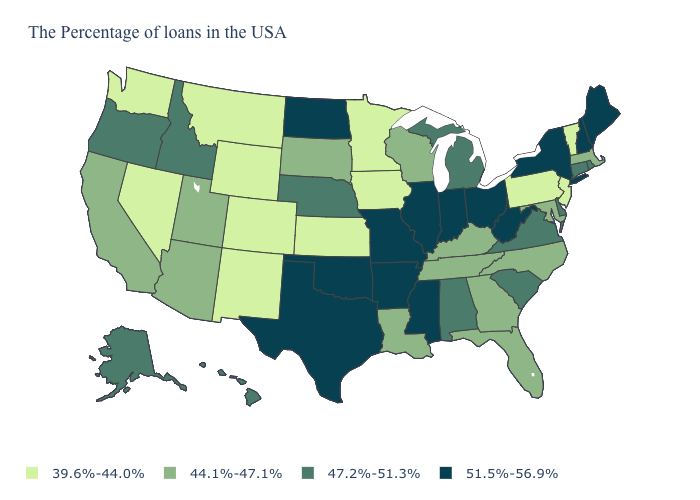Does Florida have the highest value in the South?
Concise answer only. No. Which states have the lowest value in the USA?
Be succinct. Vermont, New Jersey, Pennsylvania, Minnesota, Iowa, Kansas, Wyoming, Colorado, New Mexico, Montana, Nevada, Washington. Name the states that have a value in the range 44.1%-47.1%?
Short answer required. Massachusetts, Maryland, North Carolina, Florida, Georgia, Kentucky, Tennessee, Wisconsin, Louisiana, South Dakota, Utah, Arizona, California. How many symbols are there in the legend?
Quick response, please. 4. Does the first symbol in the legend represent the smallest category?
Answer briefly. Yes. Name the states that have a value in the range 39.6%-44.0%?
Keep it brief. Vermont, New Jersey, Pennsylvania, Minnesota, Iowa, Kansas, Wyoming, Colorado, New Mexico, Montana, Nevada, Washington. Does the first symbol in the legend represent the smallest category?
Be succinct. Yes. Among the states that border Nevada , does Oregon have the lowest value?
Quick response, please. No. Does Maryland have the same value as Illinois?
Write a very short answer. No. Name the states that have a value in the range 44.1%-47.1%?
Keep it brief. Massachusetts, Maryland, North Carolina, Florida, Georgia, Kentucky, Tennessee, Wisconsin, Louisiana, South Dakota, Utah, Arizona, California. Name the states that have a value in the range 44.1%-47.1%?
Keep it brief. Massachusetts, Maryland, North Carolina, Florida, Georgia, Kentucky, Tennessee, Wisconsin, Louisiana, South Dakota, Utah, Arizona, California. What is the value of Pennsylvania?
Quick response, please. 39.6%-44.0%. What is the value of Indiana?
Short answer required. 51.5%-56.9%. Which states have the lowest value in the USA?
Answer briefly. Vermont, New Jersey, Pennsylvania, Minnesota, Iowa, Kansas, Wyoming, Colorado, New Mexico, Montana, Nevada, Washington. What is the lowest value in the USA?
Be succinct. 39.6%-44.0%. 